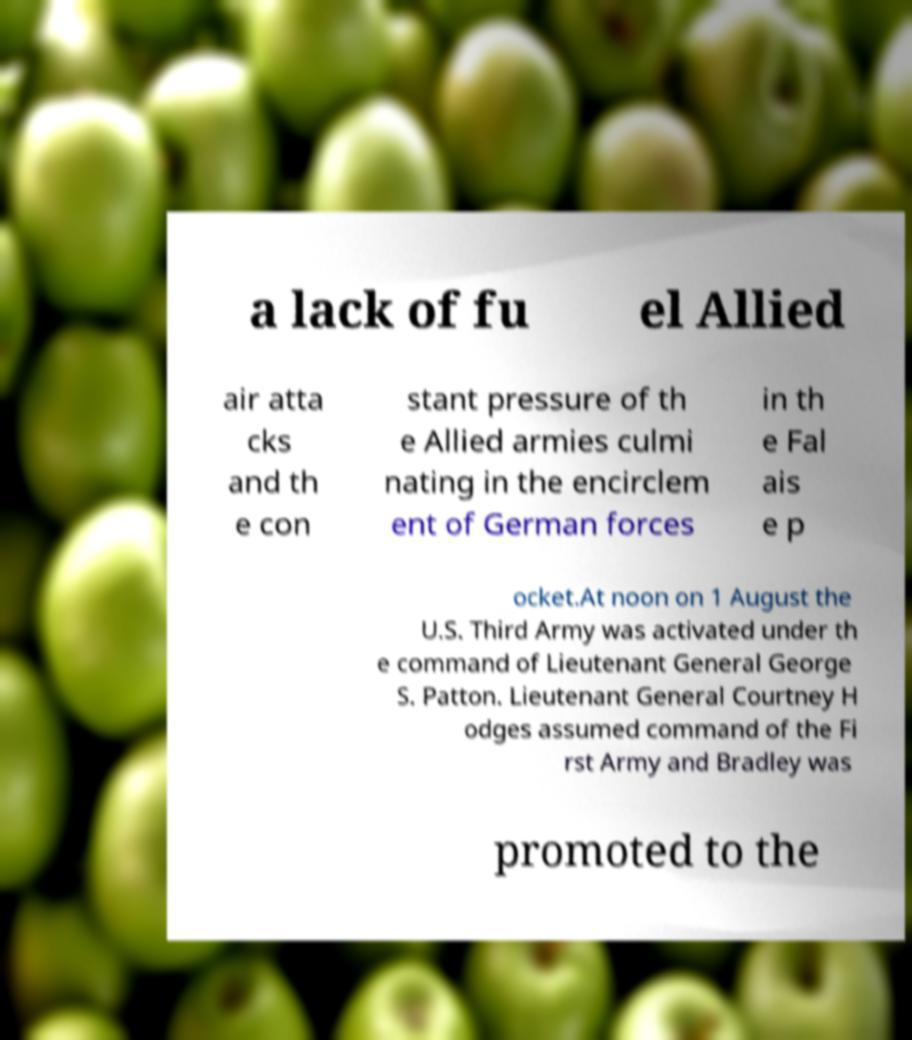Please identify and transcribe the text found in this image. a lack of fu el Allied air atta cks and th e con stant pressure of th e Allied armies culmi nating in the encirclem ent of German forces in th e Fal ais e p ocket.At noon on 1 August the U.S. Third Army was activated under th e command of Lieutenant General George S. Patton. Lieutenant General Courtney H odges assumed command of the Fi rst Army and Bradley was promoted to the 